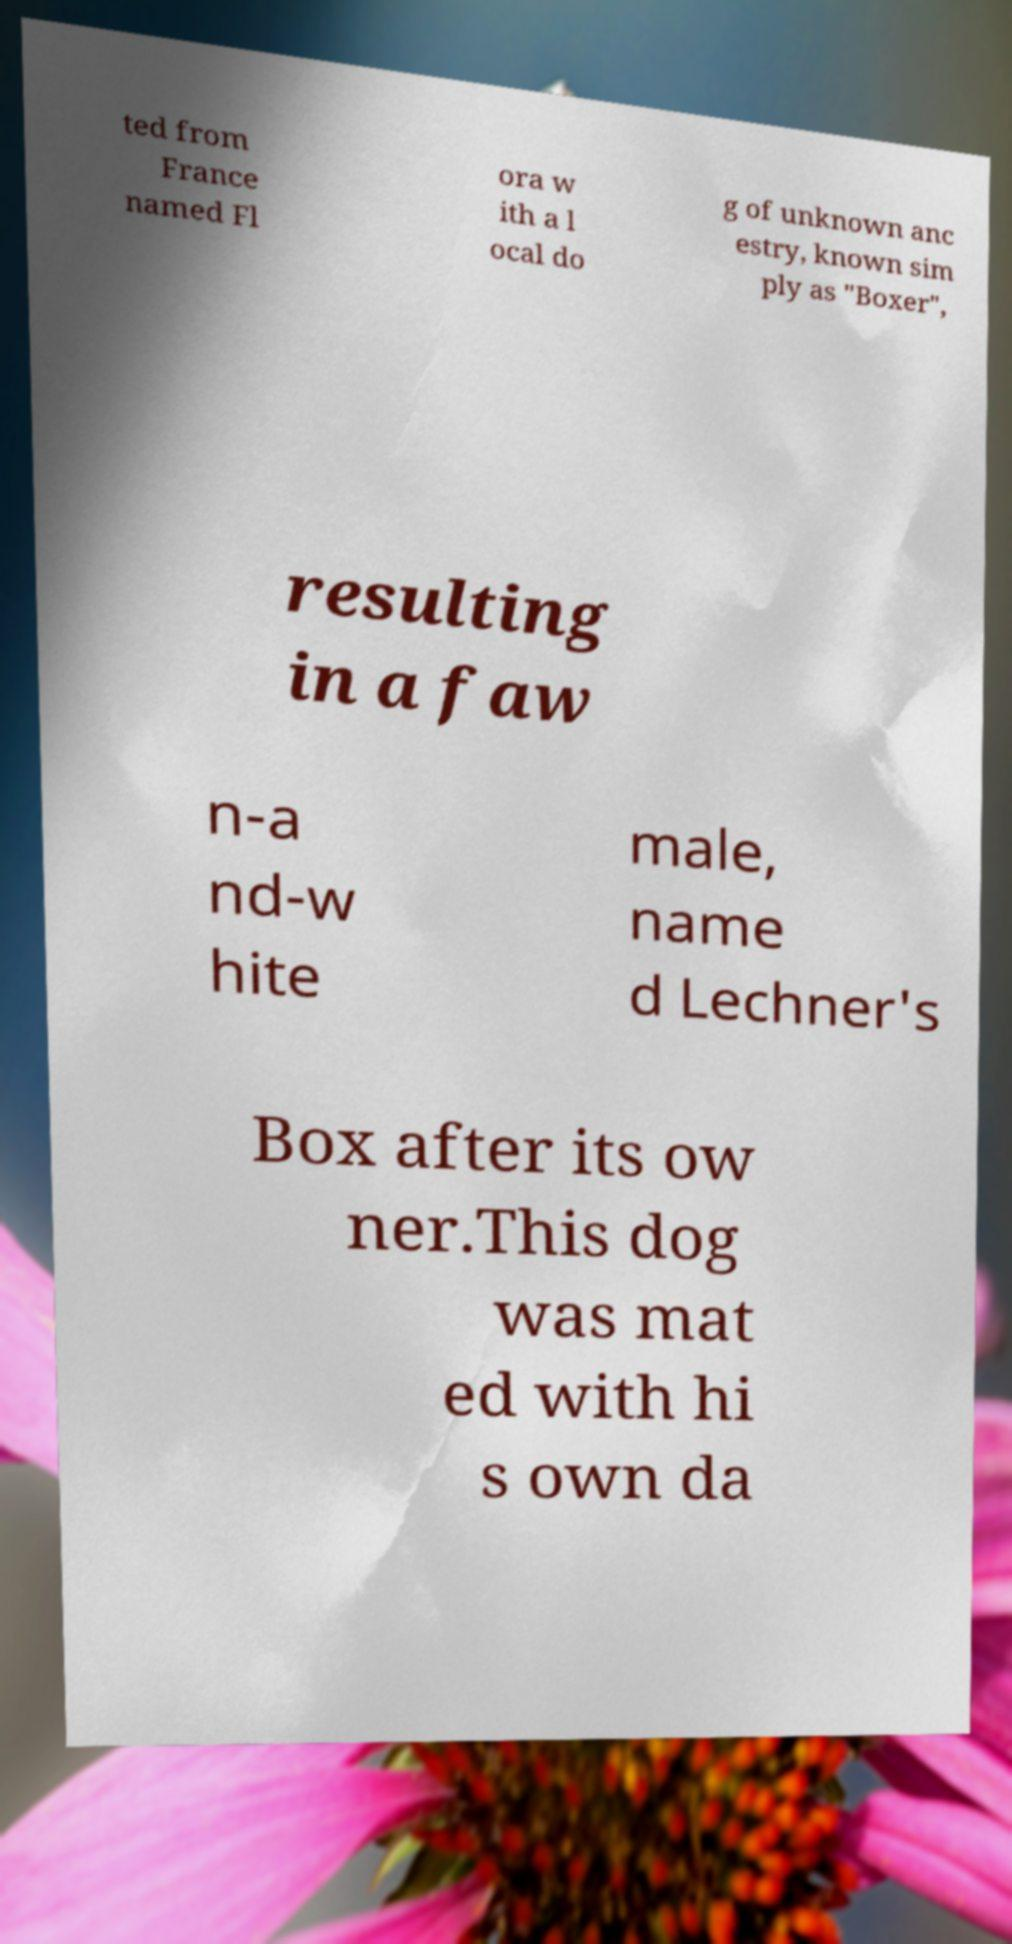I need the written content from this picture converted into text. Can you do that? ted from France named Fl ora w ith a l ocal do g of unknown anc estry, known sim ply as "Boxer", resulting in a faw n-a nd-w hite male, name d Lechner's Box after its ow ner.This dog was mat ed with hi s own da 